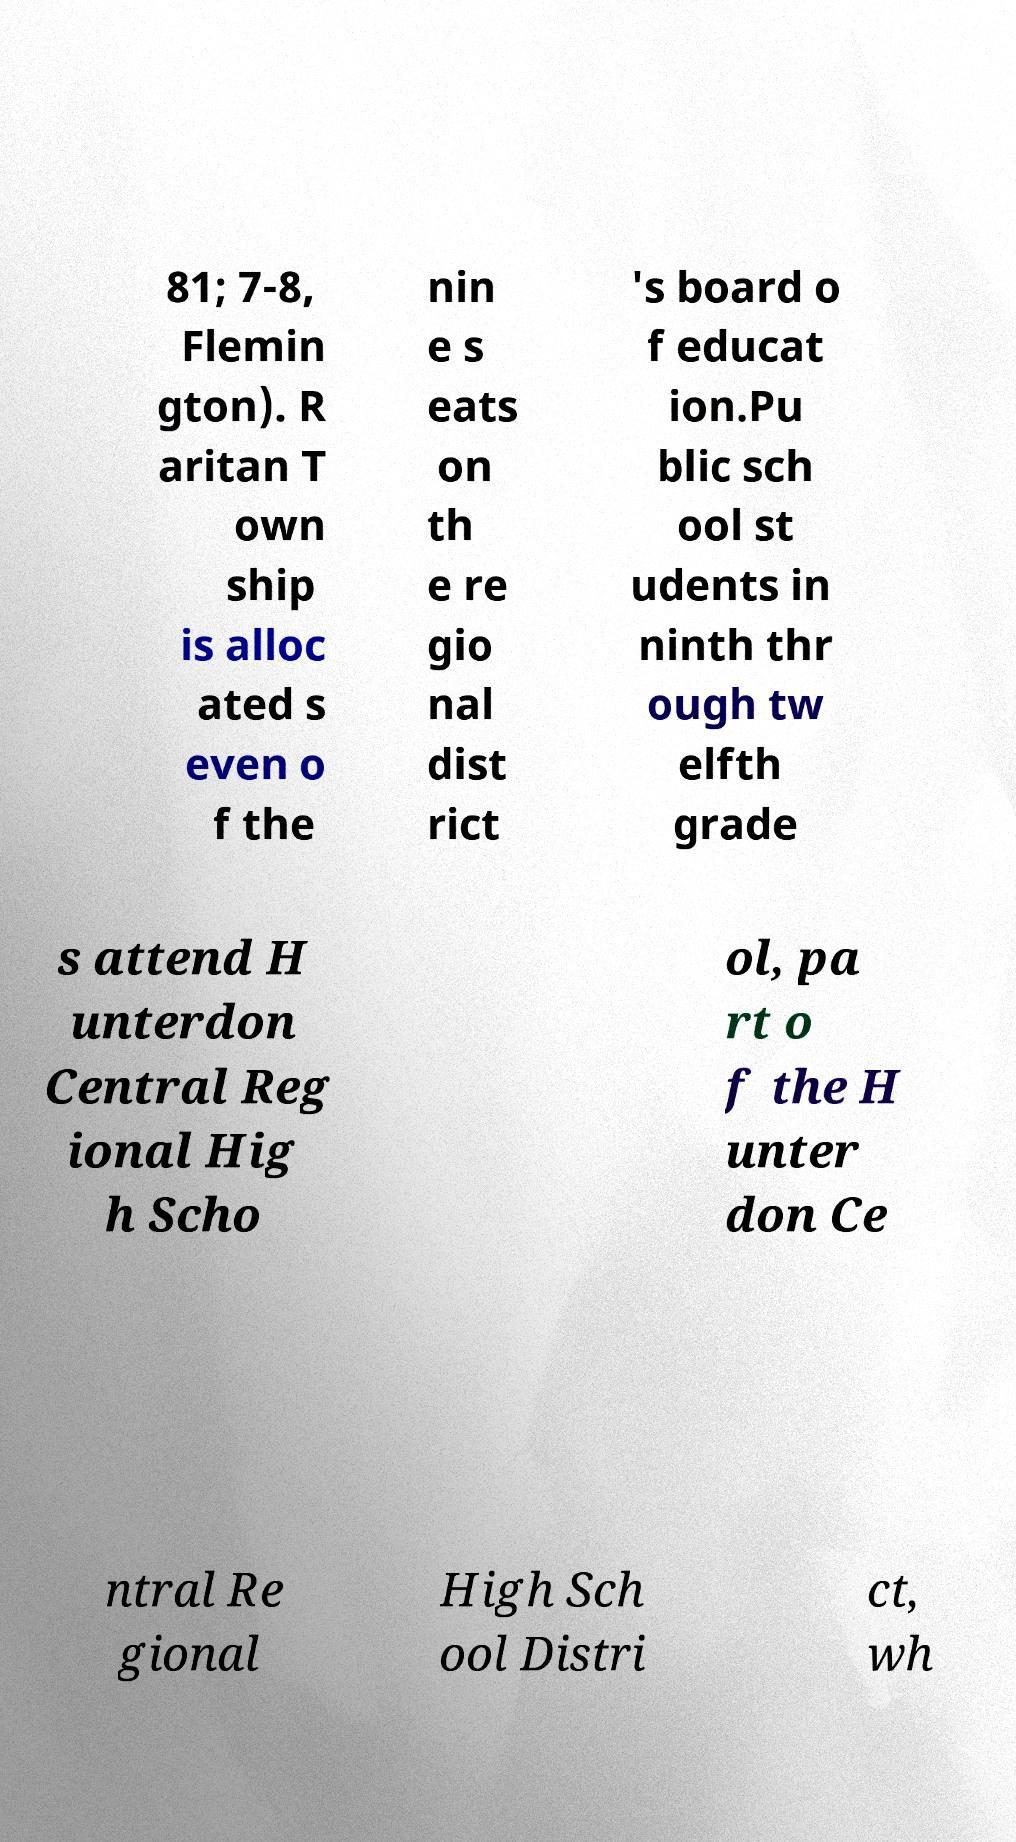I need the written content from this picture converted into text. Can you do that? 81; 7-8, Flemin gton). R aritan T own ship is alloc ated s even o f the nin e s eats on th e re gio nal dist rict 's board o f educat ion.Pu blic sch ool st udents in ninth thr ough tw elfth grade s attend H unterdon Central Reg ional Hig h Scho ol, pa rt o f the H unter don Ce ntral Re gional High Sch ool Distri ct, wh 